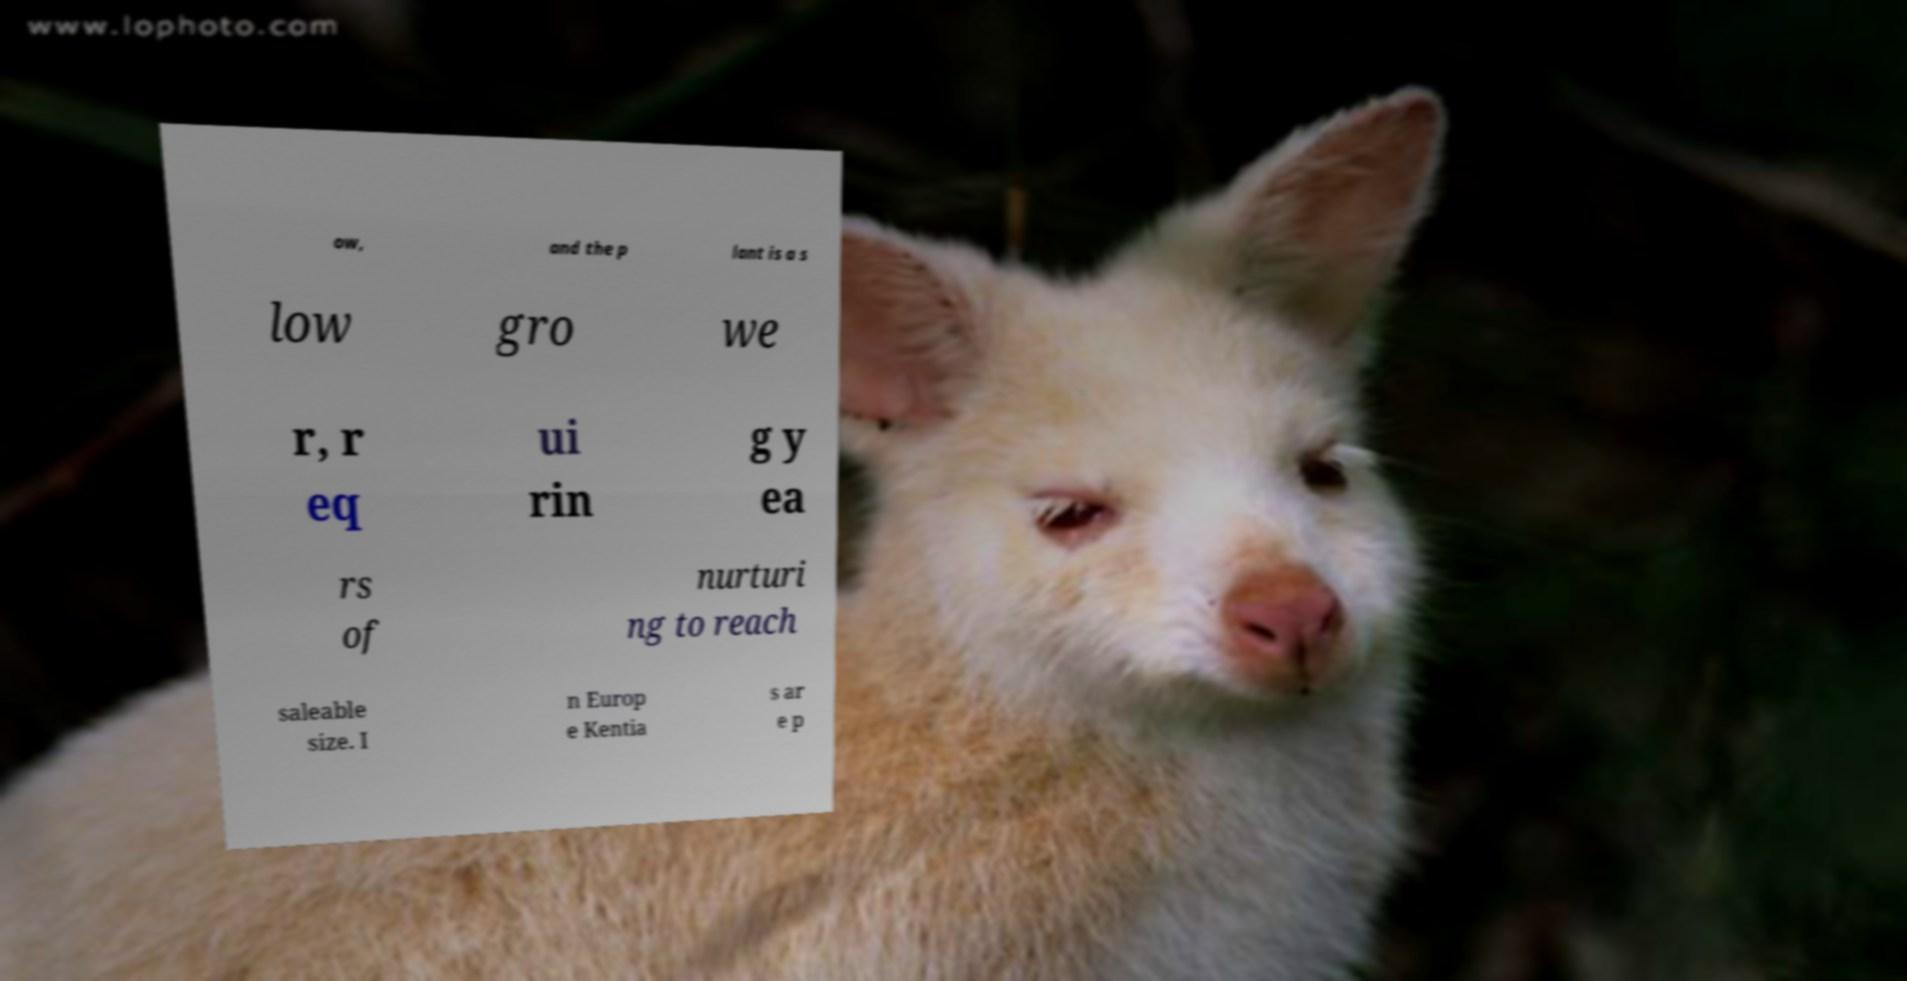Please read and relay the text visible in this image. What does it say? ow, and the p lant is a s low gro we r, r eq ui rin g y ea rs of nurturi ng to reach saleable size. I n Europ e Kentia s ar e p 